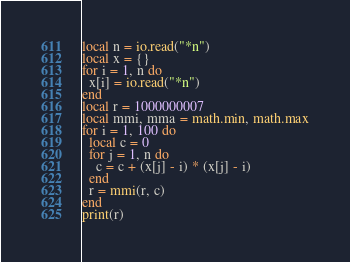Convert code to text. <code><loc_0><loc_0><loc_500><loc_500><_Lua_>local n = io.read("*n")
local x = {}
for i = 1, n do
  x[i] = io.read("*n")
end
local r = 1000000007
local mmi, mma = math.min, math.max
for i = 1, 100 do
  local c = 0
  for j = 1, n do
    c = c + (x[j] - i) * (x[j] - i)
  end
  r = mmi(r, c)
end
print(r)
</code> 